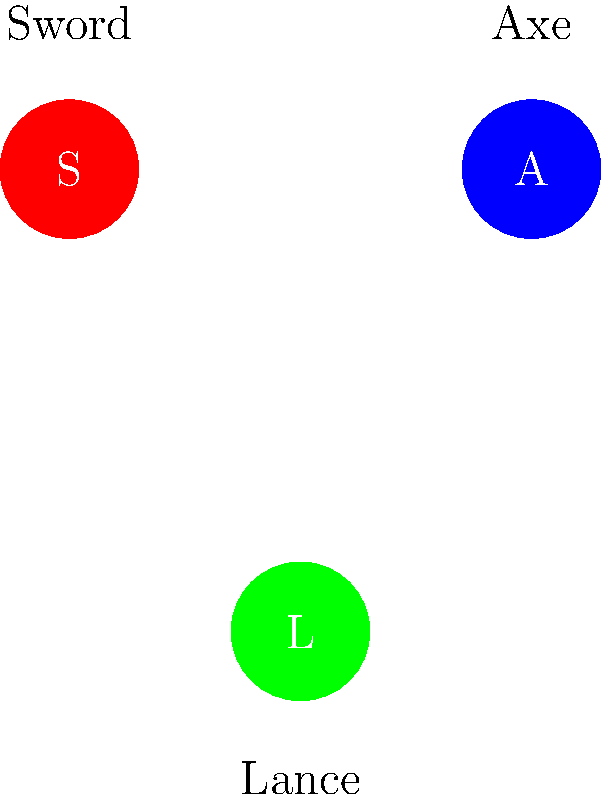Based on the weapon triangle shown in the image, which Fire Emblem character class would be most effective against an Axe-wielding enemy? To answer this question, we need to analyze the weapon triangle system in Fire Emblem:

1. The image shows three weapon types: Sword (S), Axe (A), and Lance (L).
2. In Fire Emblem, the weapon triangle determines advantages and disadvantages in combat.
3. The arrows in the triangle indicate the direction of advantage:
   - Sword has an advantage over Axe
   - Axe has an advantage over Lance
   - Lance has an advantage over Sword
4. To be most effective against an Axe-wielding enemy, we need a class that uses the weapon with an advantage over Axe.
5. Following the weapon triangle, we can see that Sword has an advantage over Axe.
6. Therefore, a character class that primarily uses Swords would be most effective against an Axe-wielding enemy.

Common Sword-wielding classes in Fire Emblem include Myrmidon, Mercenary, and Lord, but the specific answer would be any Sword-using class.
Answer: Sword-wielding class 